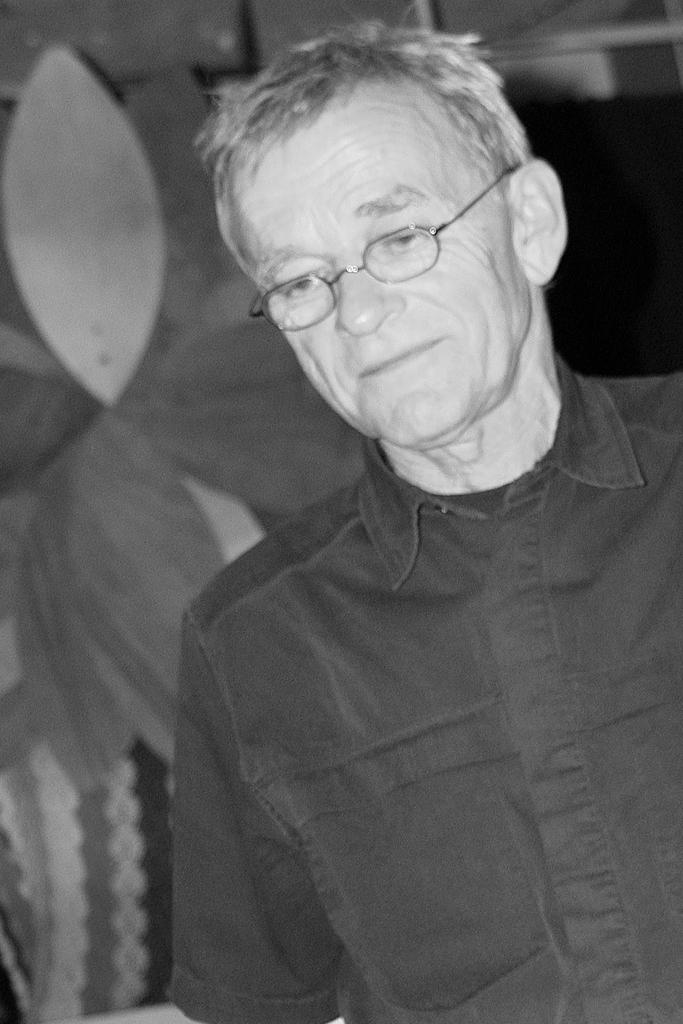What is the color scheme of the image? The image is black and white. Who is present in the image? There is an old man standing in the image. What is the old man wearing? The old man is wearing a shirt and spectacles. What can be seen in the background of the image? There is an object in the background of the image. What type of volleyball game is being played in the image? There is no volleyball game present in the image. Who is taking a picture of the old man in the image? There is no camera or photographer present in the image. 